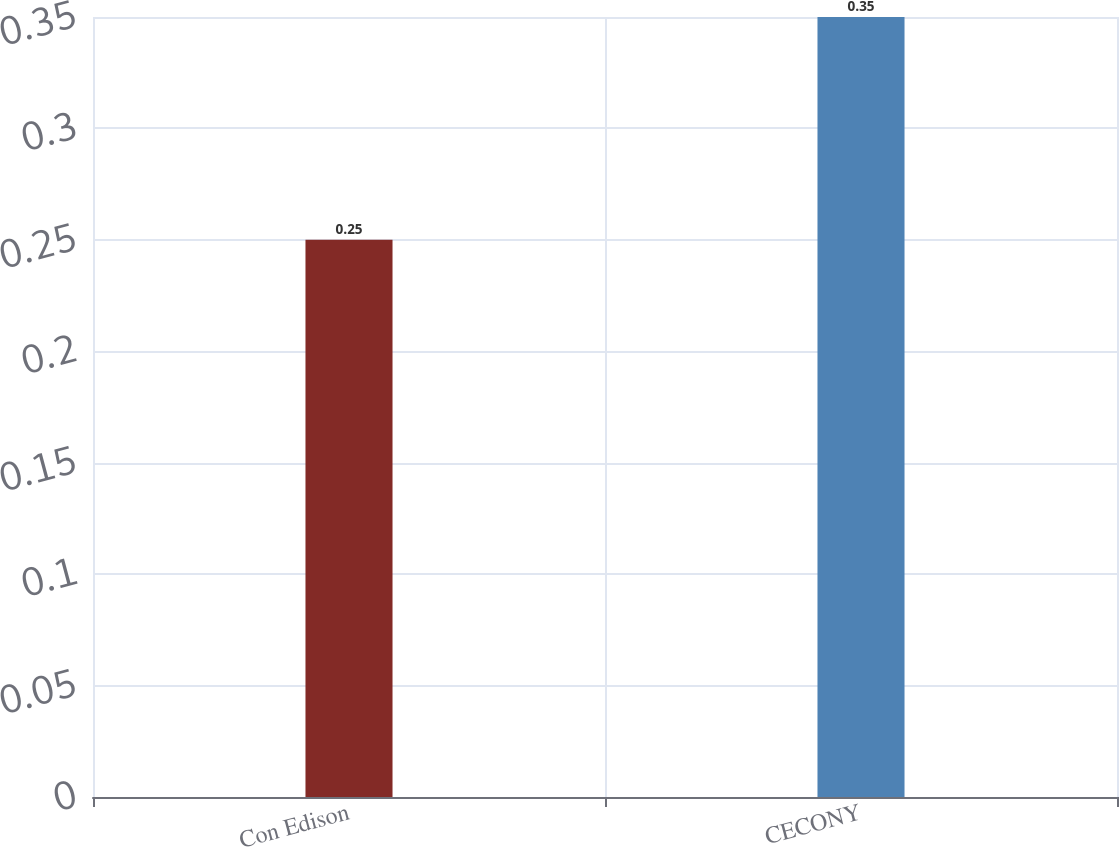Convert chart. <chart><loc_0><loc_0><loc_500><loc_500><bar_chart><fcel>Con Edison<fcel>CECONY<nl><fcel>0.25<fcel>0.35<nl></chart> 